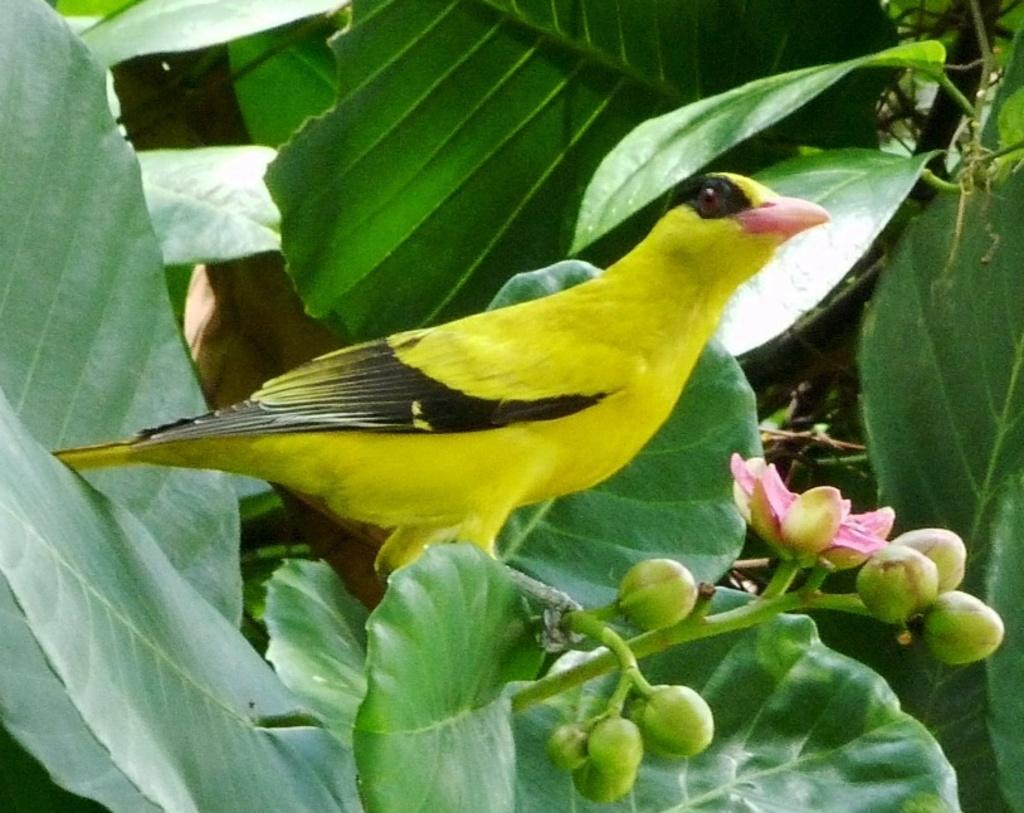What type of animal is in the image? There is a bird in the image. Where is the bird located? The bird is standing on a tree. What other flora can be seen in the image? There is a pink flower in the image. What stage of growth are the tree's flowers in? There are buds on the tree. What colors can be seen on the bird? The bird has yellow and black coloration. What flavor of ice cream is being served in the bedroom in the image? There is no ice cream or bedroom present in the image; it features a bird standing on a tree with a pink flower and buds. 